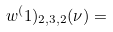Convert formula to latex. <formula><loc_0><loc_0><loc_500><loc_500>w ^ { ( } 1 ) _ { 2 , 3 , 2 } ( \nu ) =</formula> 